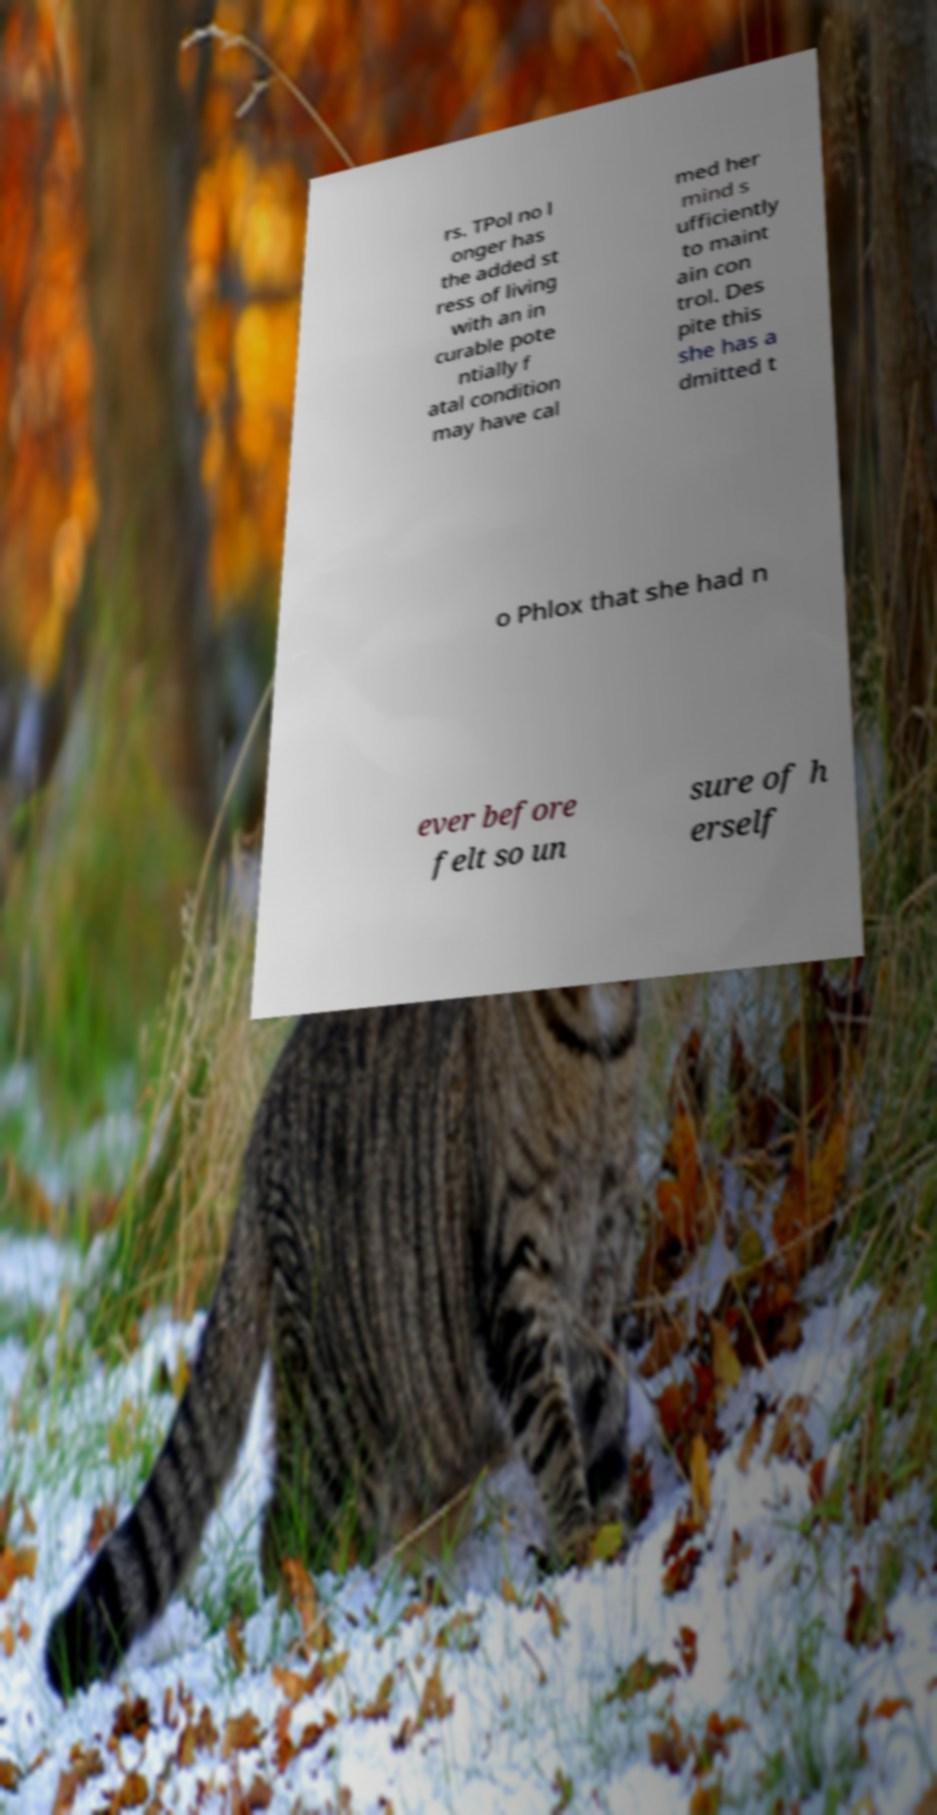Could you assist in decoding the text presented in this image and type it out clearly? rs. TPol no l onger has the added st ress of living with an in curable pote ntially f atal condition may have cal med her mind s ufficiently to maint ain con trol. Des pite this she has a dmitted t o Phlox that she had n ever before felt so un sure of h erself 